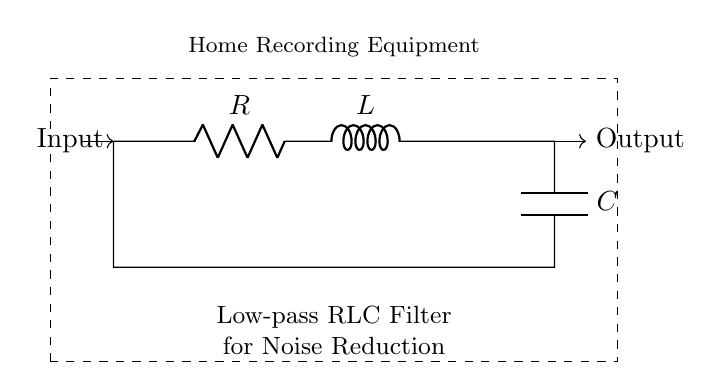What components are in the circuit? The circuit contains a resistor, an inductor, and a capacitor, indicated by the respective symbols R, L, and C.
Answer: Resistor, Inductor, Capacitor What is the function of this circuit? The circuit is designed as a low-pass filter, which allows low-frequency signals to pass while reducing higher-frequency noise.
Answer: Low-pass filter What is the primary purpose of the filter? The filter is used for noise reduction specifically in home recording equipment, helping to improve audio quality by eliminating unwanted high-frequency noise.
Answer: Noise reduction How many elements are in series in this circuit? The resistor, inductor, and capacitor are all connected in series, meaning there are three elements in total.
Answer: Three What is the effect of increasing the value of the resistor? Increasing the resistor's value would result in a larger voltage drop and potentially reduce the signal level, affecting how the filter responds to signals. This change may lead to a higher cutoff frequency, allowing more higher-frequency noise to pass.
Answer: Higher cutoff frequency What type of filter is created by this arrangement of RLC components? The circuit creates a second-order low-pass filter, as the RLC components introduce a resonance effect that affects both frequency response and phase shift.
Answer: Second-order low-pass filter What might happen if the values of L and C are equal? If the values of L and C are equal, the circuit will resonate at the specific frequency determined by those values, which could lead to amplification at that frequency and may defeat the noise reduction purpose.
Answer: Resonance occurs 